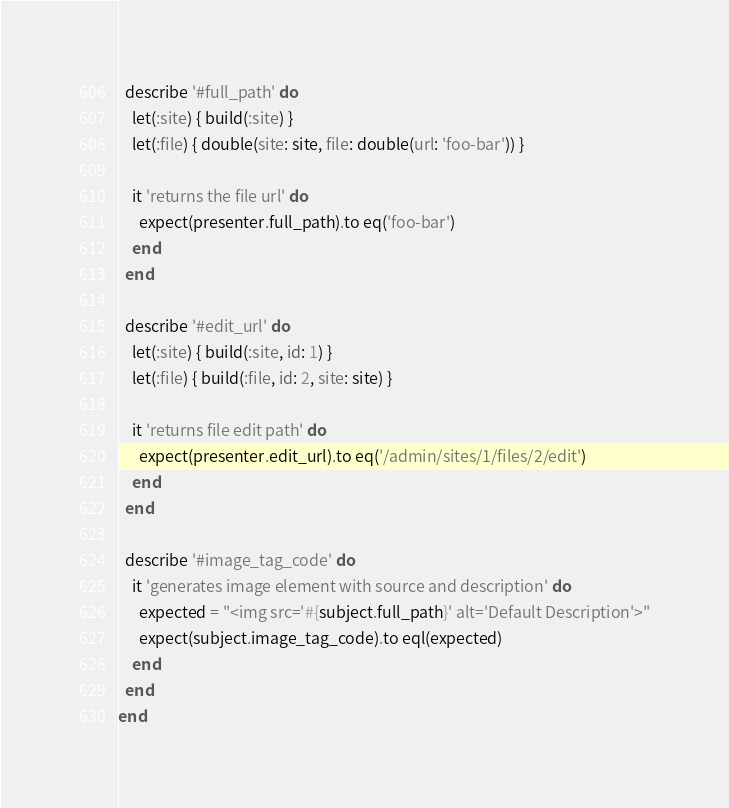Convert code to text. <code><loc_0><loc_0><loc_500><loc_500><_Ruby_>  describe '#full_path' do
    let(:site) { build(:site) }
    let(:file) { double(site: site, file: double(url: 'foo-bar')) }

    it 'returns the file url' do
      expect(presenter.full_path).to eq('foo-bar')
    end
  end

  describe '#edit_url' do
    let(:site) { build(:site, id: 1) }
    let(:file) { build(:file, id: 2, site: site) }

    it 'returns file edit path' do
      expect(presenter.edit_url).to eq('/admin/sites/1/files/2/edit')
    end
  end

  describe '#image_tag_code' do
    it 'generates image element with source and description' do
      expected = "<img src='#{subject.full_path}' alt='Default Description'>"
      expect(subject.image_tag_code).to eql(expected)
    end
  end
end
</code> 